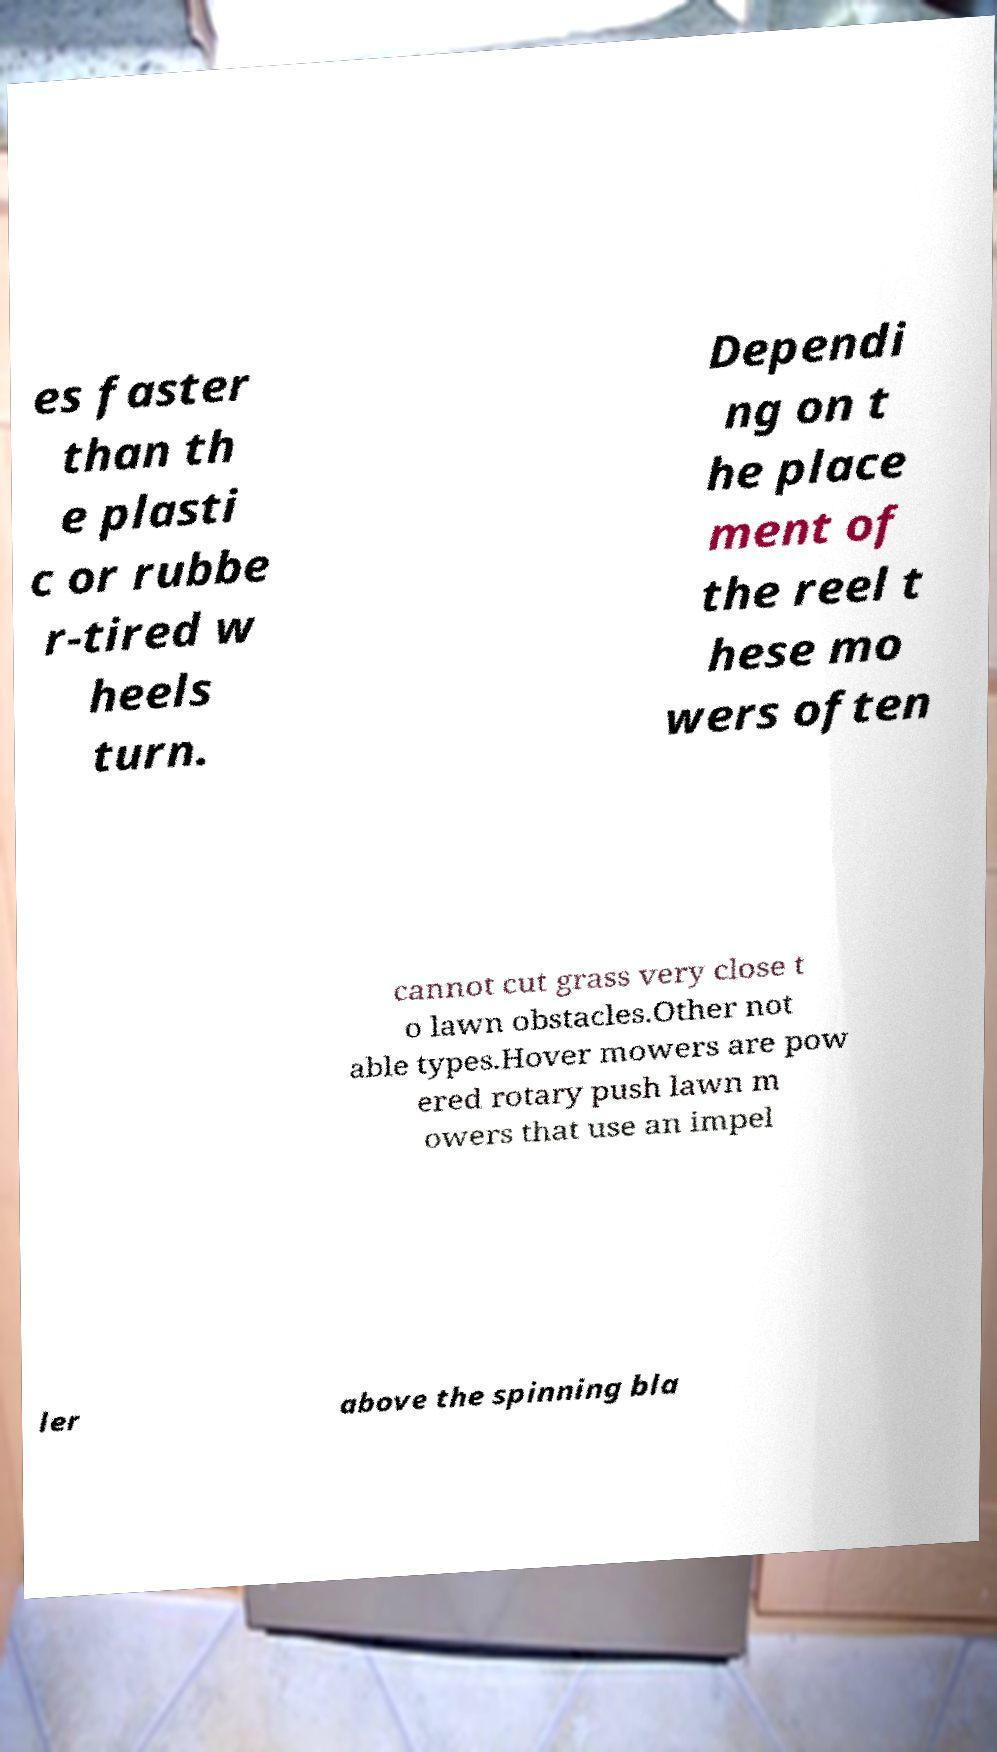Could you assist in decoding the text presented in this image and type it out clearly? es faster than th e plasti c or rubbe r-tired w heels turn. Dependi ng on t he place ment of the reel t hese mo wers often cannot cut grass very close t o lawn obstacles.Other not able types.Hover mowers are pow ered rotary push lawn m owers that use an impel ler above the spinning bla 